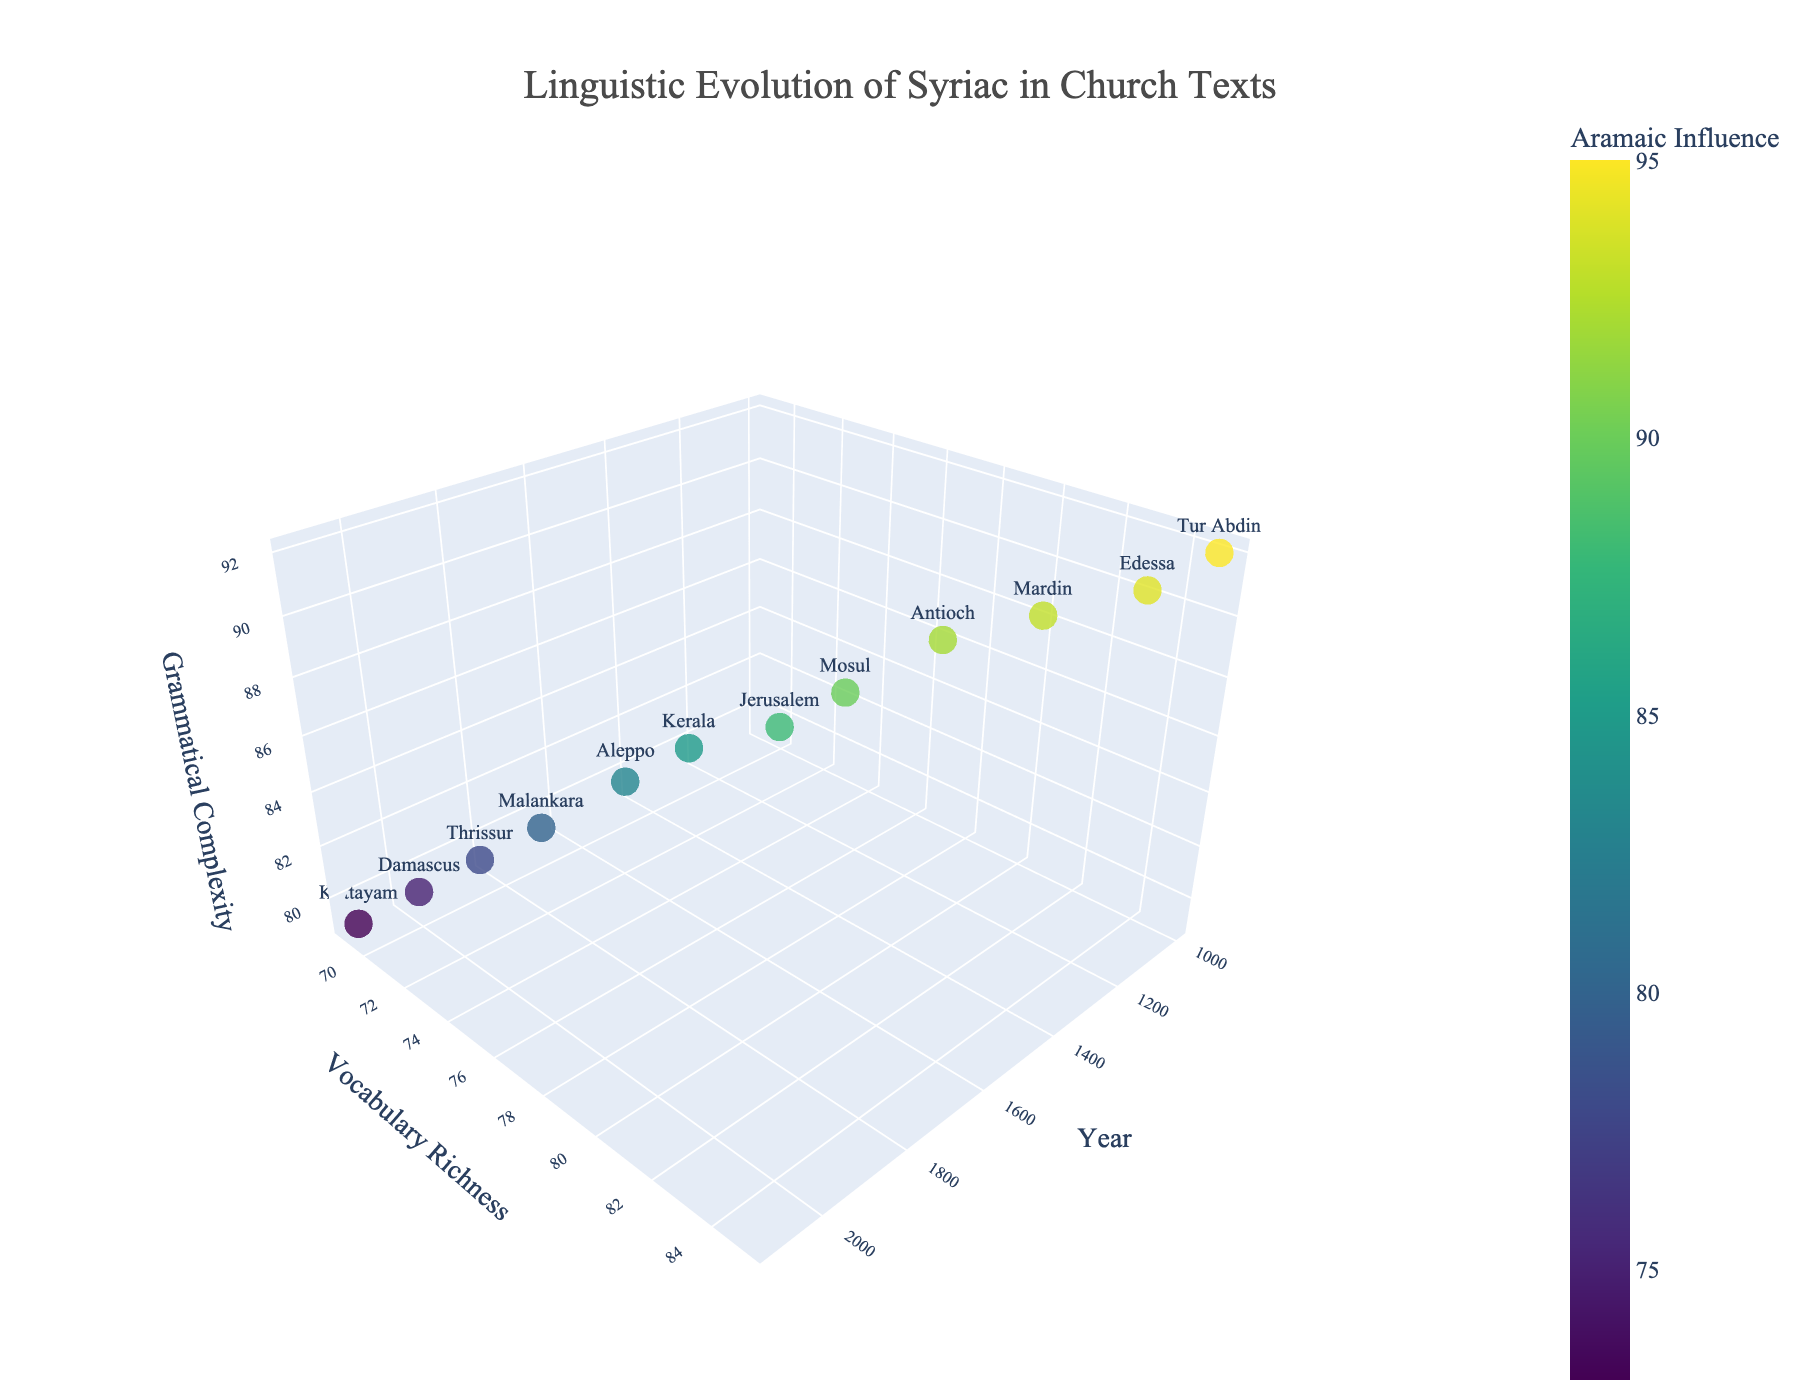What's the title of the plot? The title of the plot is usually displayed prominently at the top of the figure. In this case, it is "Linguistic Evolution of Syriac in Church Texts".
Answer: Linguistic Evolution of Syriac in Church Texts What are the axis labels for the 3D plot? The axis labels are usually found next to the respective axes. In this figure, the x-axis is labeled "Year", the y-axis is labeled "Vocabulary Richness", and the z-axis is labeled "Grammatical Complexity".
Answer: Year, Vocabulary Richness, Grammatical Complexity Which region has the highest grammatical complexity and what year does it correspond to? To answer this, identify the point with the highest value on the z-axis and check its corresponding text label showing the region and the x-axis value showing the year. The highest grammatical complexity value is 92, corresponding to Tur Abdin in the year 1000.
Answer: Tur Abdin, 1000 How does the Aramaic influence change over time? Since the plot uses color to denote Aramaic influence, you can observe how the color changes across years. Specifically, the color shifts from darker (higher influence) in earlier years to lighter (lower influence) in later years.
Answer: Decreases over time What is the vocabulary richness and grammatical complexity for the region Kottayam in the year 2100? Locate Kottayam in the figure, which is the text label for the point corresponding to the year 2100 on the x-axis. The coordinates provide the values: Vocabulary Richness is 69 and Grammatical Complexity is 79.
Answer: 69, 79 Compare the vocabulary richness between the regions Aleppo in 1700 and Thrissur in 1900. Find the data points for Aleppo (1700) and Thrissur (1900) and compare their y-axis values. Aleppo has a richness of 74, while Thrissur has a richness of 71, so Aleppo's vocabulary richness is higher.
Answer: Aleppo: 74, Thrissur: 71 Which year shows the lowest Aramaic influence and what is its value? Identify the data point closest to the lightest color (indicating the lowest influence) and note the corresponding year and value. The year 2100 in Kottayam has the lowest influence with a value of 73.
Answer: 2100, 73 Between the years 1400 and 1800, which region exhibited the greatest decline in grammatical complexity? Compare the grammatical complexity values of Mosul (1400) with 90, Kerala (1600) with 85, and Malankara (1800) with 80. Therefore, over this period, Mosul shows the greatest decline from 87 to 82, which is a drop of 5.
Answer: Mosul, declined by 7 Calculate the average grammatical complexity for the regions in the years 1100, 1300, and 1500. First, identify the values: Edessa (1100) with 91, Antioch (1300) with 89, and Jerusalem (1500) with 86. Sum these values (91 + 89 + 86 = 266) and divide by the number of data points (3), which equals 88.67.
Answer: 88.67 Which region had the highest vocabulary richness in the year 1300, 1400, or 1500? Look at the y-axis values for Antioch (1300) with 80, Mosul (1400) with 78, and Jerusalem (1500) with 77. The highest value among these is for Antioch in 1300.
Answer: Antioch 